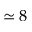Convert formula to latex. <formula><loc_0><loc_0><loc_500><loc_500>\simeq 8</formula> 